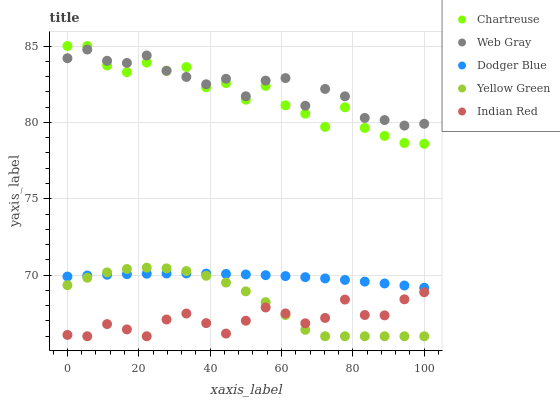Does Indian Red have the minimum area under the curve?
Answer yes or no. Yes. Does Web Gray have the maximum area under the curve?
Answer yes or no. Yes. Does Dodger Blue have the minimum area under the curve?
Answer yes or no. No. Does Dodger Blue have the maximum area under the curve?
Answer yes or no. No. Is Dodger Blue the smoothest?
Answer yes or no. Yes. Is Chartreuse the roughest?
Answer yes or no. Yes. Is Web Gray the smoothest?
Answer yes or no. No. Is Web Gray the roughest?
Answer yes or no. No. Does Yellow Green have the lowest value?
Answer yes or no. Yes. Does Dodger Blue have the lowest value?
Answer yes or no. No. Does Chartreuse have the highest value?
Answer yes or no. Yes. Does Web Gray have the highest value?
Answer yes or no. No. Is Yellow Green less than Chartreuse?
Answer yes or no. Yes. Is Web Gray greater than Indian Red?
Answer yes or no. Yes. Does Indian Red intersect Yellow Green?
Answer yes or no. Yes. Is Indian Red less than Yellow Green?
Answer yes or no. No. Is Indian Red greater than Yellow Green?
Answer yes or no. No. Does Yellow Green intersect Chartreuse?
Answer yes or no. No. 